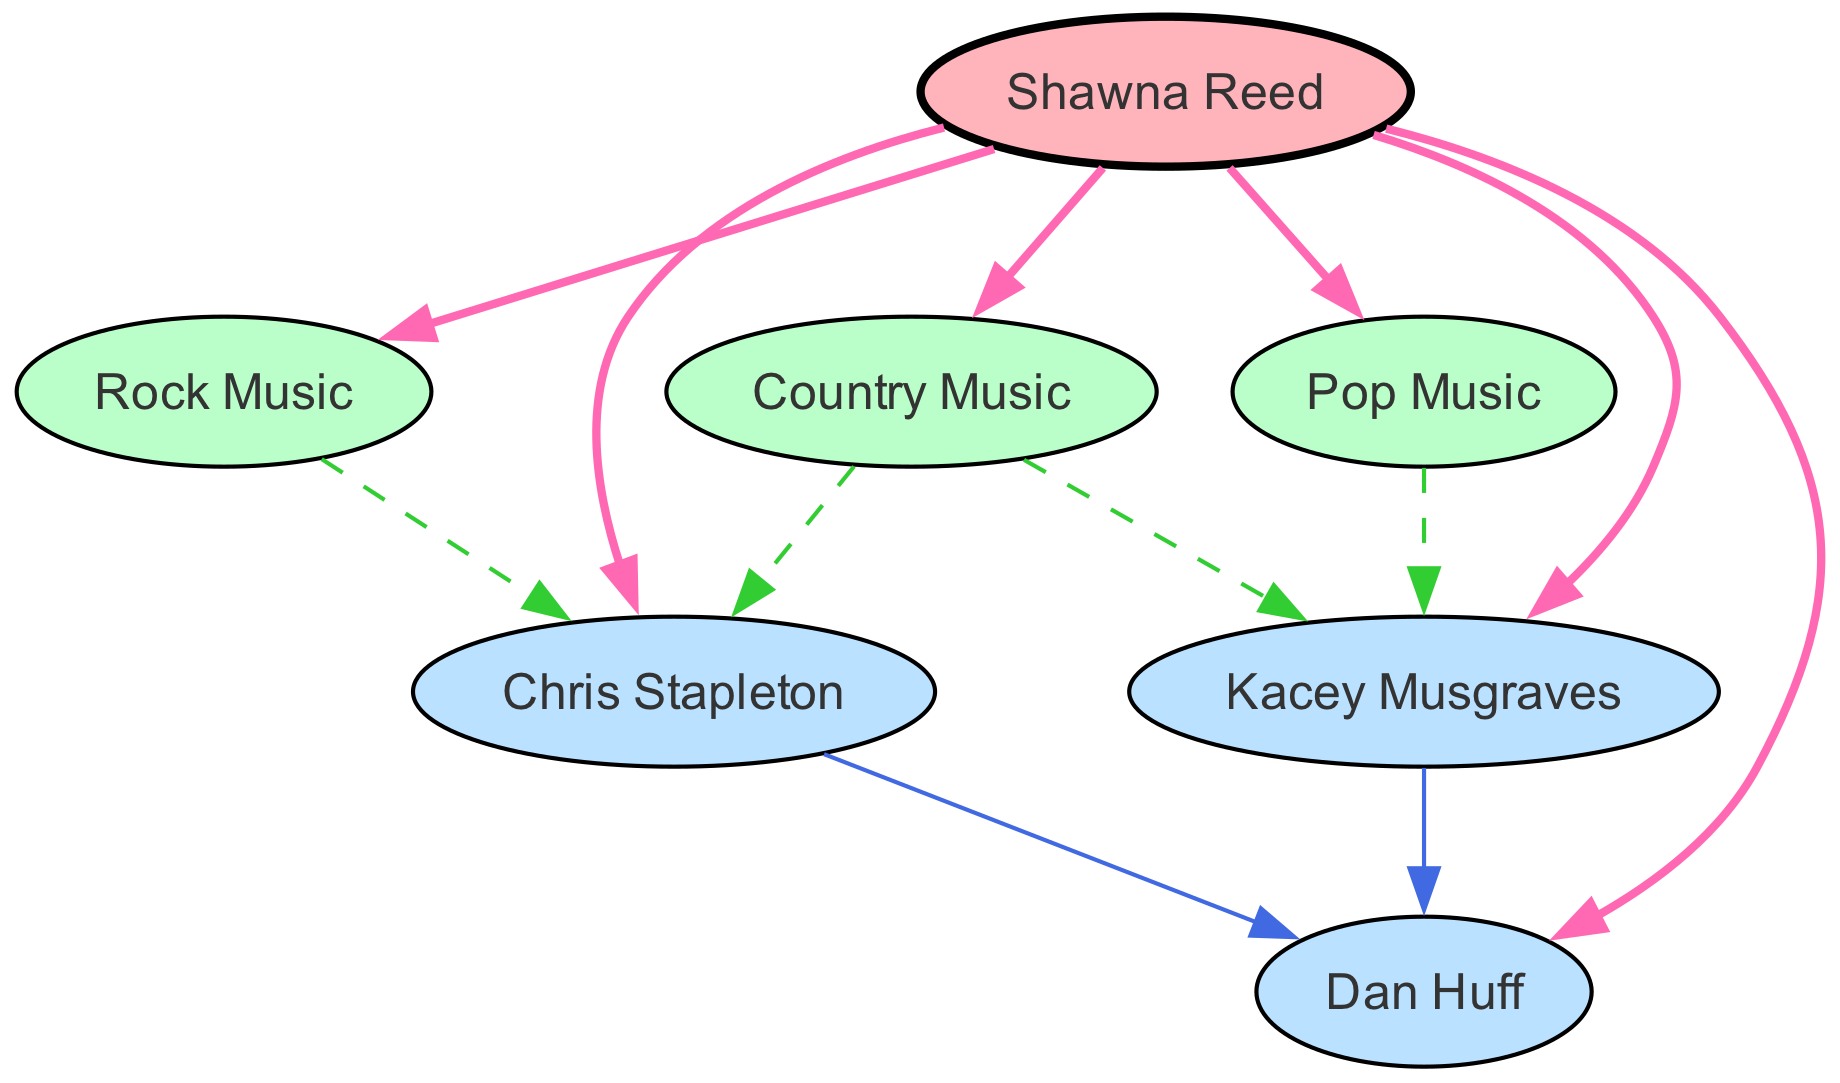What influences Shawna Reed's music style? The diagram shows three direct influences on Shawna Reed's music: Country Music, Rock Music, and Pop Music. These influences are indicated by the edges connecting Shawna Reed to each genre.
Answer: Country Music, Rock Music, Pop Music How many collaborators are linked to Shawna Reed? In the diagram, there are three connections from Shawna Reed to collaborators: Chris Stapleton, Kacey Musgraves, and Dan Huff. This indicates that she is associated with three different collaborators.
Answer: 3 What type of music does Chris Stapleton influence? The diagram illustrates that Chris Stapleton is influenced by Country Music and Rock Music, as shown by the directed edges from the genre nodes to Chris Stapleton.
Answer: Country Music, Rock Music Which genre influences Kacey Musgraves the most? The directed edges in the diagram show that Kacey Musgraves is influenced mainly by Country Music and Pop Music, with a direct edge from those genre nodes to Kacey Musgraves.
Answer: Country Music, Pop Music What is the relationship between Shawna Reed and Dan Huff? Dan Huff appears in the diagram as a collaborator linked to Shawna Reed through directed edges from both Chris Stapleton and Kacey Musgraves, indicating that he is a producer collaborating with her and her collaborators.
Answer: Collaborator How many total edges are there in the diagram? By counting all the edges listed in the edges section of the data, it shows there are a total of 12 edges representing relationships and influences among the nodes in the directed graph.
Answer: 12 Which two artists collaborate with the same producer? The diagram shows that both Chris Stapleton and Kacey Musgraves collaborate with the producer Dan Huff, as there are directed edges leading from each artist to Dan Huff in the graph.
Answer: Chris Stapleton, Kacey Musgraves Which music influences are linked to Chris Stapleton? The connections in the diagram lead from both Country Music and Rock Music to Chris Stapleton, demonstrating that these two genres have a direct influence on his music style.
Answer: Country Music, Rock Music What is the primary influence that connects to both Kacey Musgraves and Chris Stapleton? The diagram indicates that Country Music is the primary influence that connects both Kacey Musgraves and Chris Stapleton, as both have directed edges linking them to this genre.
Answer: Country Music 